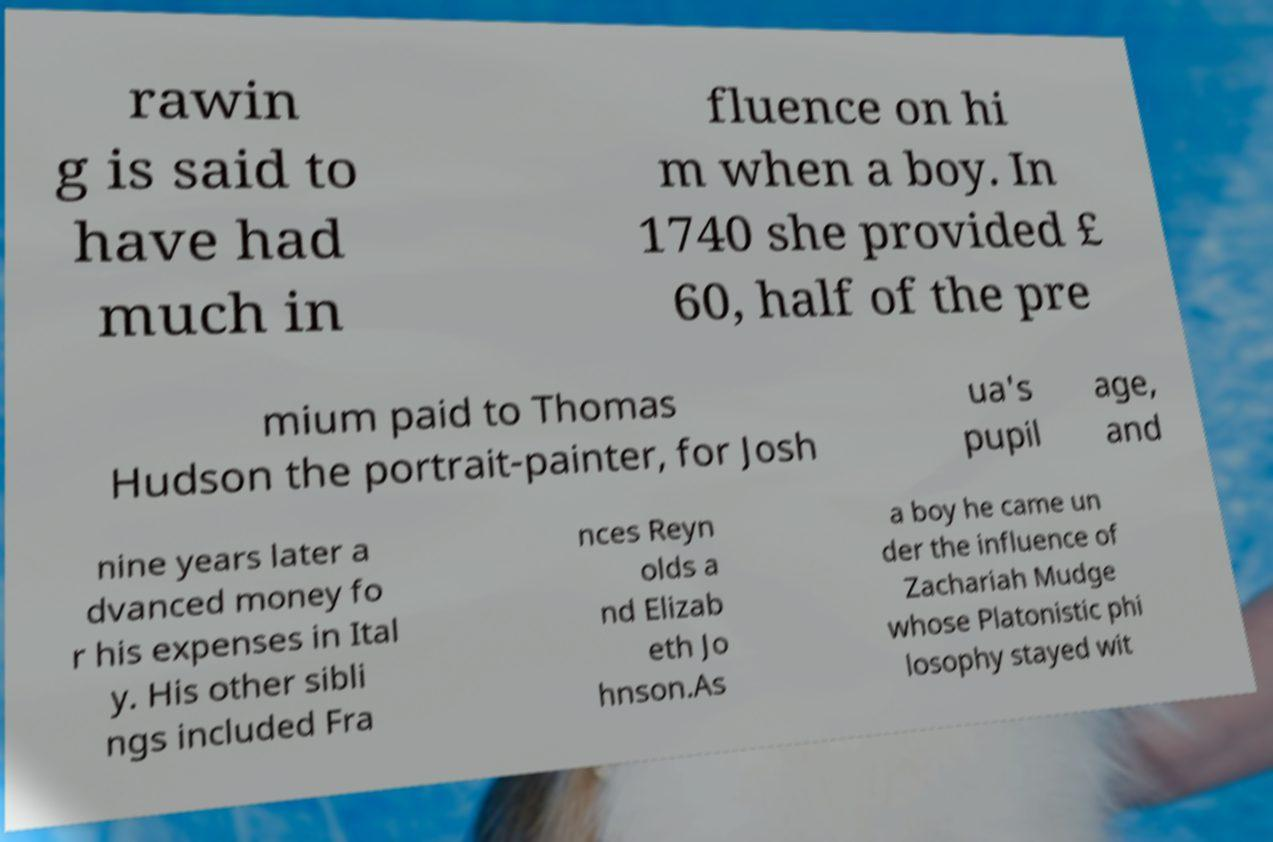Can you read and provide the text displayed in the image?This photo seems to have some interesting text. Can you extract and type it out for me? rawin g is said to have had much in fluence on hi m when a boy. In 1740 she provided £ 60, half of the pre mium paid to Thomas Hudson the portrait-painter, for Josh ua's pupil age, and nine years later a dvanced money fo r his expenses in Ital y. His other sibli ngs included Fra nces Reyn olds a nd Elizab eth Jo hnson.As a boy he came un der the influence of Zachariah Mudge whose Platonistic phi losophy stayed wit 